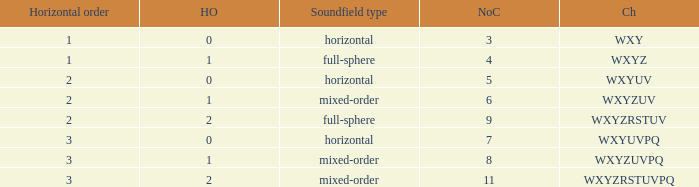If the height order is 1 and the soundfield type is mixed-order, what are all the channels? WXYZUV, WXYZUVPQ. Parse the full table. {'header': ['Horizontal order', 'HO', 'Soundfield type', 'NoC', 'Ch'], 'rows': [['1', '0', 'horizontal', '3', 'WXY'], ['1', '1', 'full-sphere', '4', 'WXYZ'], ['2', '0', 'horizontal', '5', 'WXYUV'], ['2', '1', 'mixed-order', '6', 'WXYZUV'], ['2', '2', 'full-sphere', '9', 'WXYZRSTUV'], ['3', '0', 'horizontal', '7', 'WXYUVPQ'], ['3', '1', 'mixed-order', '8', 'WXYZUVPQ'], ['3', '2', 'mixed-order', '11', 'WXYZRSTUVPQ']]} 